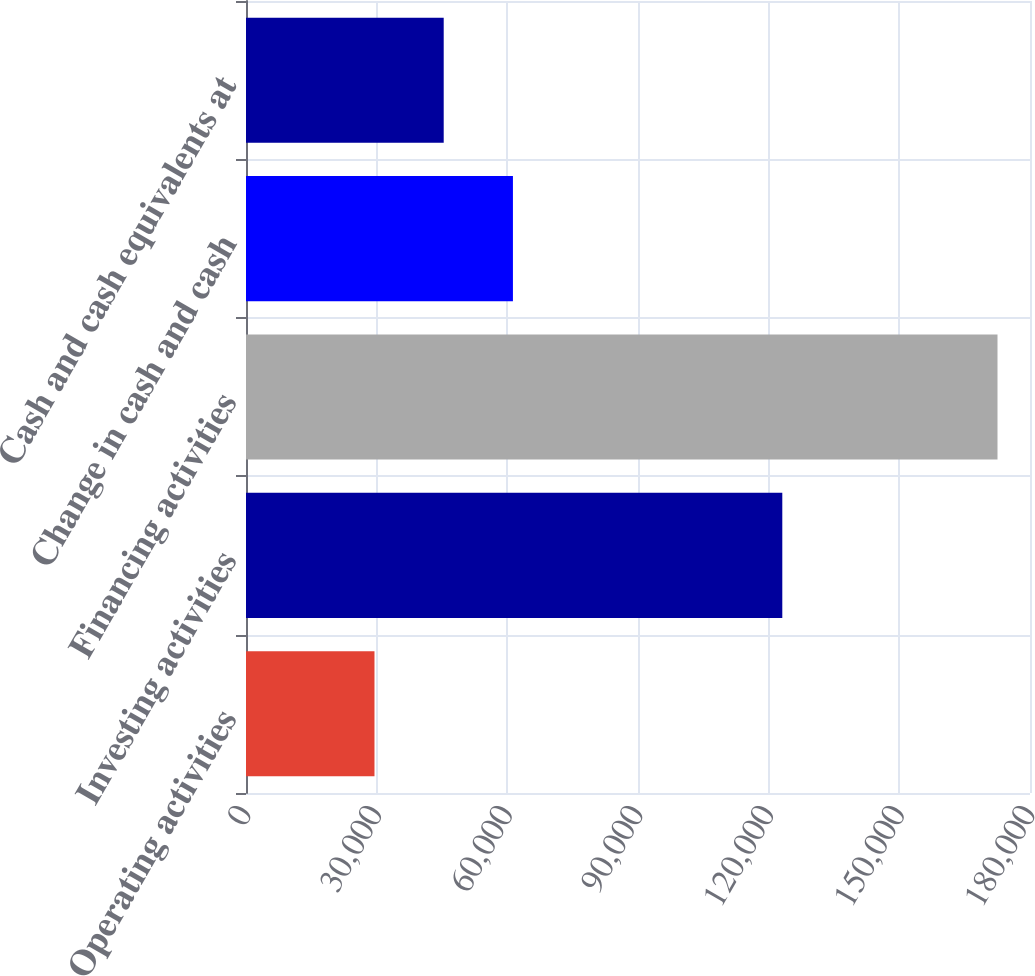Convert chart to OTSL. <chart><loc_0><loc_0><loc_500><loc_500><bar_chart><fcel>Operating activities<fcel>Investing activities<fcel>Financing activities<fcel>Change in cash and cash<fcel>Cash and cash equivalents at<nl><fcel>29498.5<fcel>123130<fcel>172540<fcel>61285.5<fcel>45392<nl></chart> 